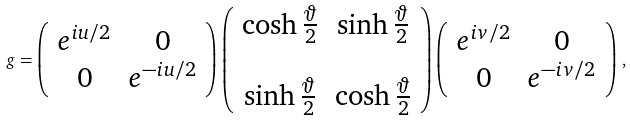Convert formula to latex. <formula><loc_0><loc_0><loc_500><loc_500>g = \left ( \begin{array} { c c } e ^ { i u / 2 } & 0 \\ 0 & e ^ { - i u / 2 } \end{array} \right ) \left ( \begin{array} { c c } \cosh \frac { \vartheta } { 2 } & \sinh \frac { \vartheta } { 2 } \\ & \\ \sinh \frac { \vartheta } { 2 } & \cosh \frac { \vartheta } { 2 } \end{array} \right ) \left ( \begin{array} { c c } e ^ { i v / 2 } & 0 \\ 0 & e ^ { - i v / 2 } \end{array} \right ) \, ,</formula> 